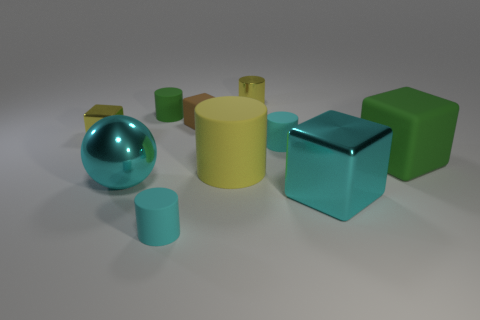How many cyan cubes are the same material as the green cylinder?
Provide a short and direct response. 0. Does the cyan rubber object on the right side of the yellow matte cylinder have the same size as the big sphere?
Your answer should be very brief. No. The big sphere that is the same material as the cyan block is what color?
Offer a very short reply. Cyan. Is there anything else that is the same size as the yellow rubber thing?
Your answer should be very brief. Yes. There is a yellow matte thing; what number of cyan rubber cylinders are behind it?
Provide a succinct answer. 1. Is the color of the rubber block in front of the small yellow cube the same as the small matte cylinder that is in front of the big green block?
Provide a succinct answer. No. What is the color of the other tiny thing that is the same shape as the tiny brown thing?
Your response must be concise. Yellow. Is there anything else that is the same shape as the brown matte object?
Your answer should be compact. Yes. Do the small cyan rubber object that is behind the big green rubber cube and the green object that is on the right side of the large cyan cube have the same shape?
Offer a very short reply. No. There is a shiny ball; is its size the same as the green object to the right of the yellow matte cylinder?
Your answer should be very brief. Yes. 